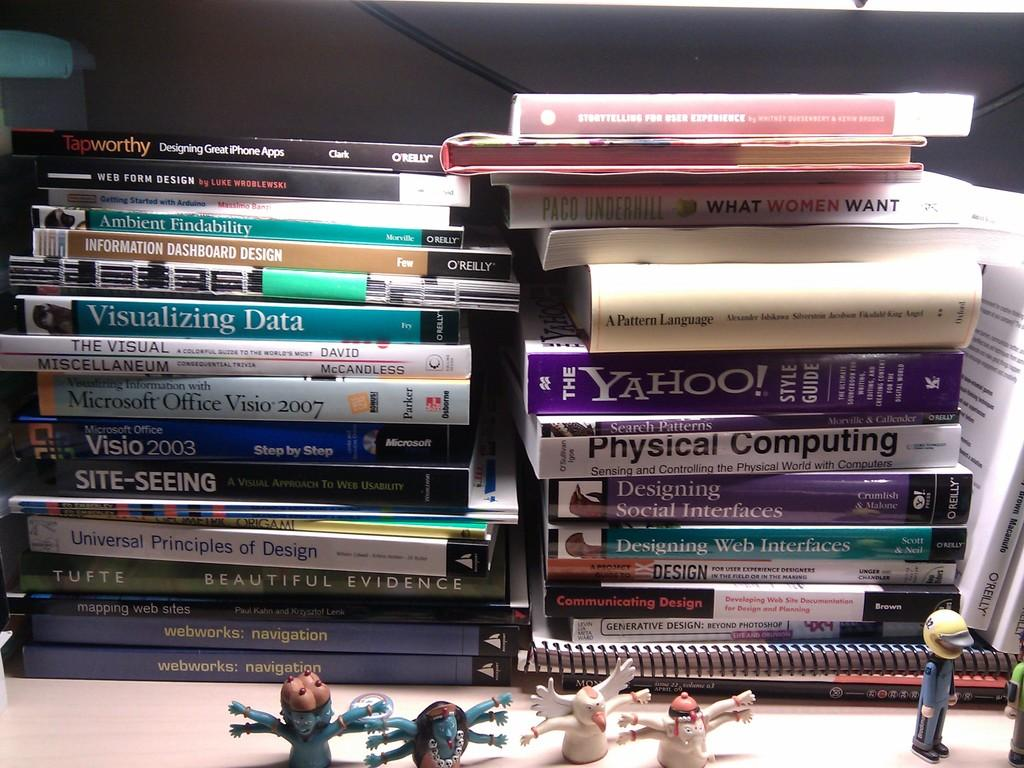<image>
Present a compact description of the photo's key features. Several books piled together including one about Yahoo! 